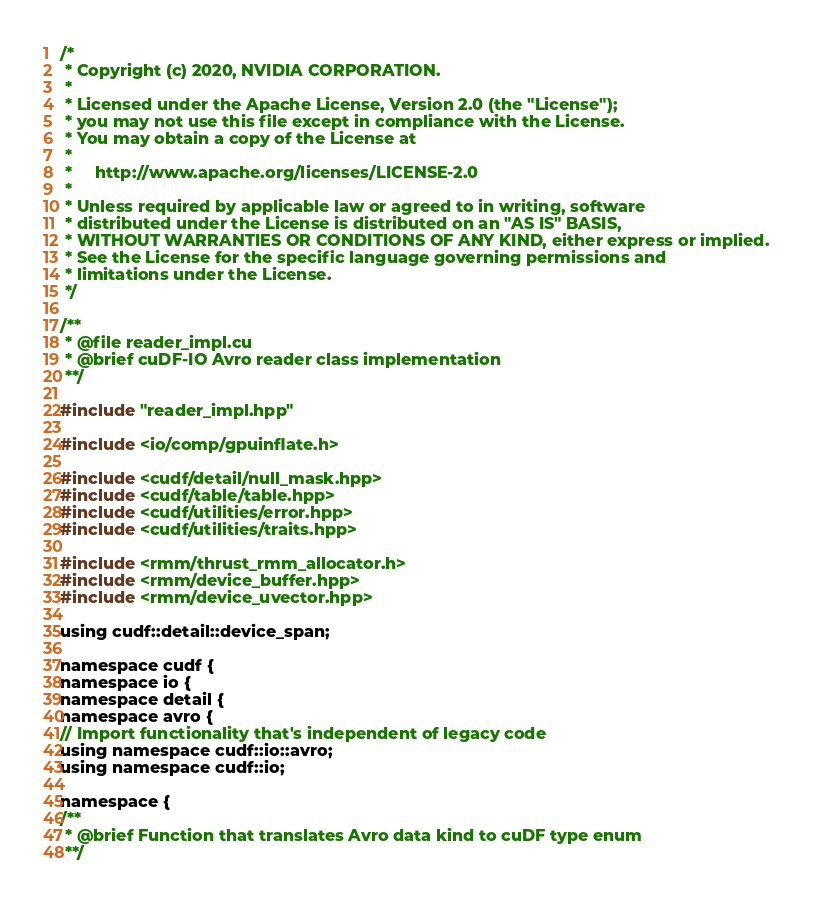<code> <loc_0><loc_0><loc_500><loc_500><_Cuda_>/*
 * Copyright (c) 2020, NVIDIA CORPORATION.
 *
 * Licensed under the Apache License, Version 2.0 (the "License");
 * you may not use this file except in compliance with the License.
 * You may obtain a copy of the License at
 *
 *     http://www.apache.org/licenses/LICENSE-2.0
 *
 * Unless required by applicable law or agreed to in writing, software
 * distributed under the License is distributed on an "AS IS" BASIS,
 * WITHOUT WARRANTIES OR CONDITIONS OF ANY KIND, either express or implied.
 * See the License for the specific language governing permissions and
 * limitations under the License.
 */

/**
 * @file reader_impl.cu
 * @brief cuDF-IO Avro reader class implementation
 **/

#include "reader_impl.hpp"

#include <io/comp/gpuinflate.h>

#include <cudf/detail/null_mask.hpp>
#include <cudf/table/table.hpp>
#include <cudf/utilities/error.hpp>
#include <cudf/utilities/traits.hpp>

#include <rmm/thrust_rmm_allocator.h>
#include <rmm/device_buffer.hpp>
#include <rmm/device_uvector.hpp>

using cudf::detail::device_span;

namespace cudf {
namespace io {
namespace detail {
namespace avro {
// Import functionality that's independent of legacy code
using namespace cudf::io::avro;
using namespace cudf::io;

namespace {
/**
 * @brief Function that translates Avro data kind to cuDF type enum
 **/</code> 